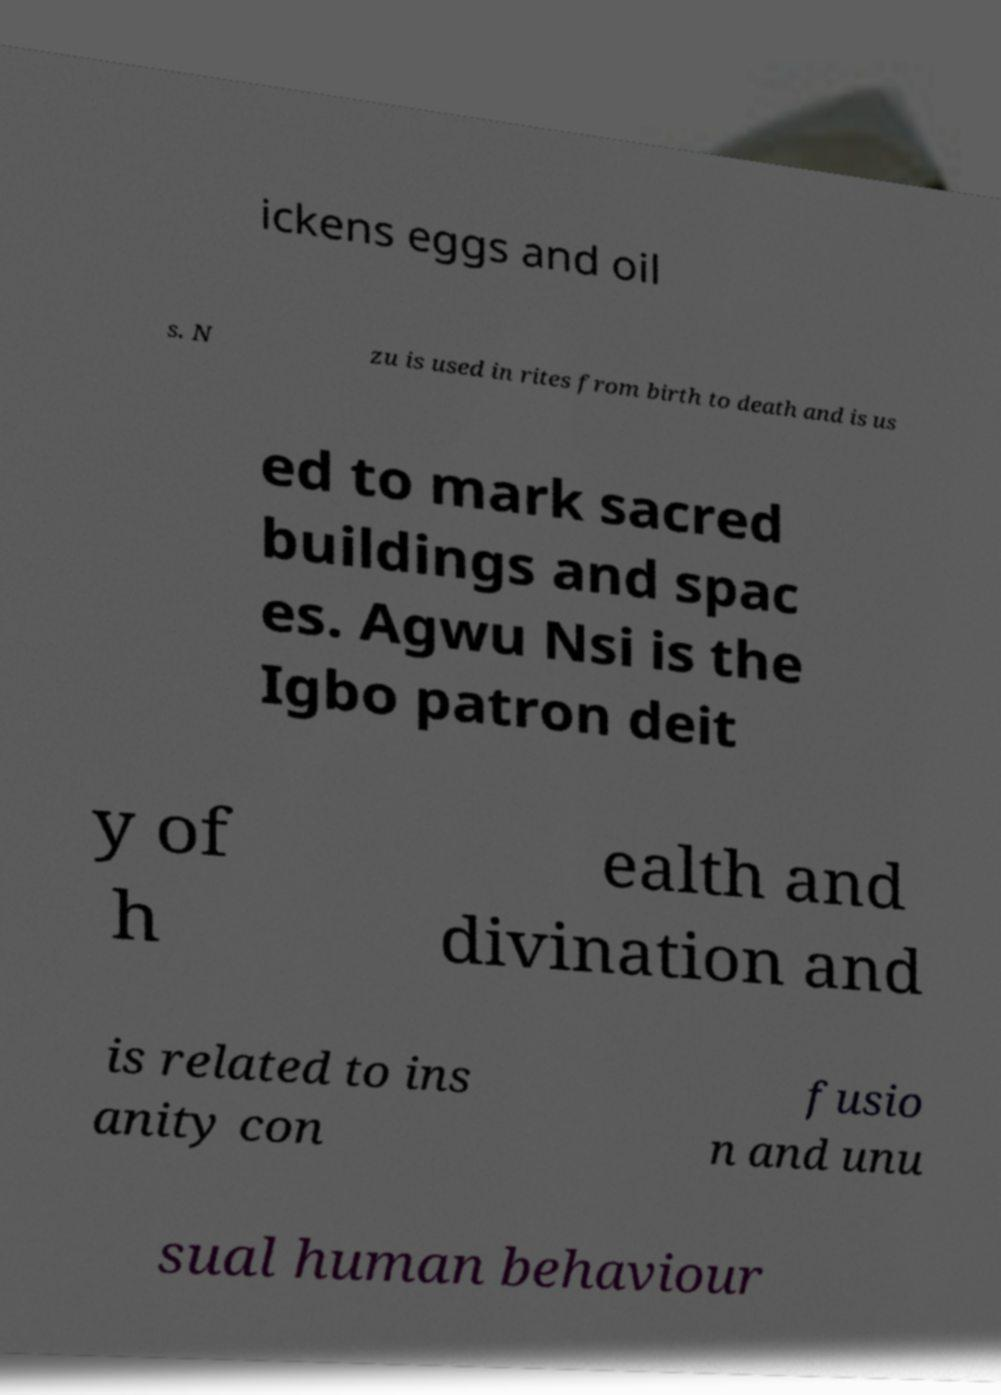What messages or text are displayed in this image? I need them in a readable, typed format. ickens eggs and oil s. N zu is used in rites from birth to death and is us ed to mark sacred buildings and spac es. Agwu Nsi is the Igbo patron deit y of h ealth and divination and is related to ins anity con fusio n and unu sual human behaviour 